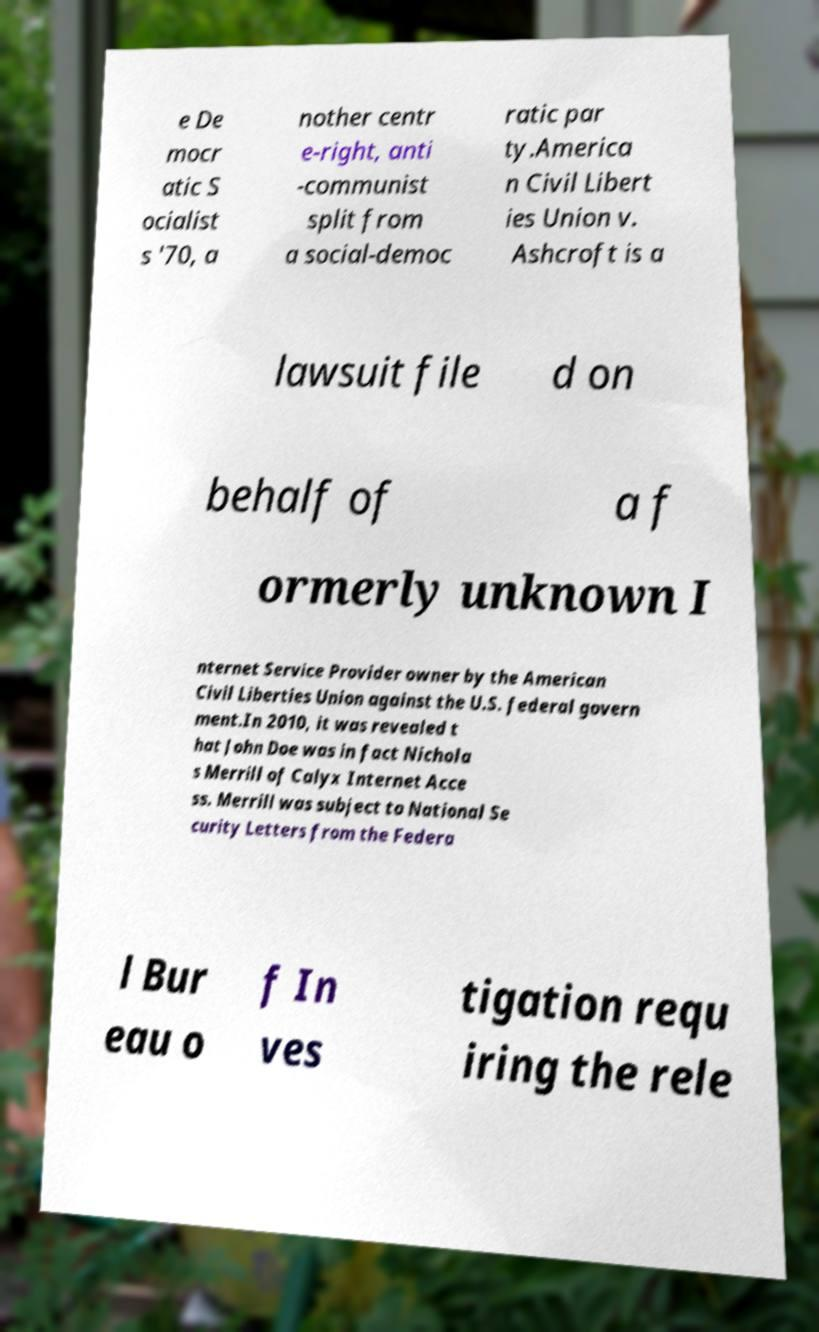Please identify and transcribe the text found in this image. e De mocr atic S ocialist s '70, a nother centr e-right, anti -communist split from a social-democ ratic par ty.America n Civil Libert ies Union v. Ashcroft is a lawsuit file d on behalf of a f ormerly unknown I nternet Service Provider owner by the American Civil Liberties Union against the U.S. federal govern ment.In 2010, it was revealed t hat John Doe was in fact Nichola s Merrill of Calyx Internet Acce ss. Merrill was subject to National Se curity Letters from the Federa l Bur eau o f In ves tigation requ iring the rele 